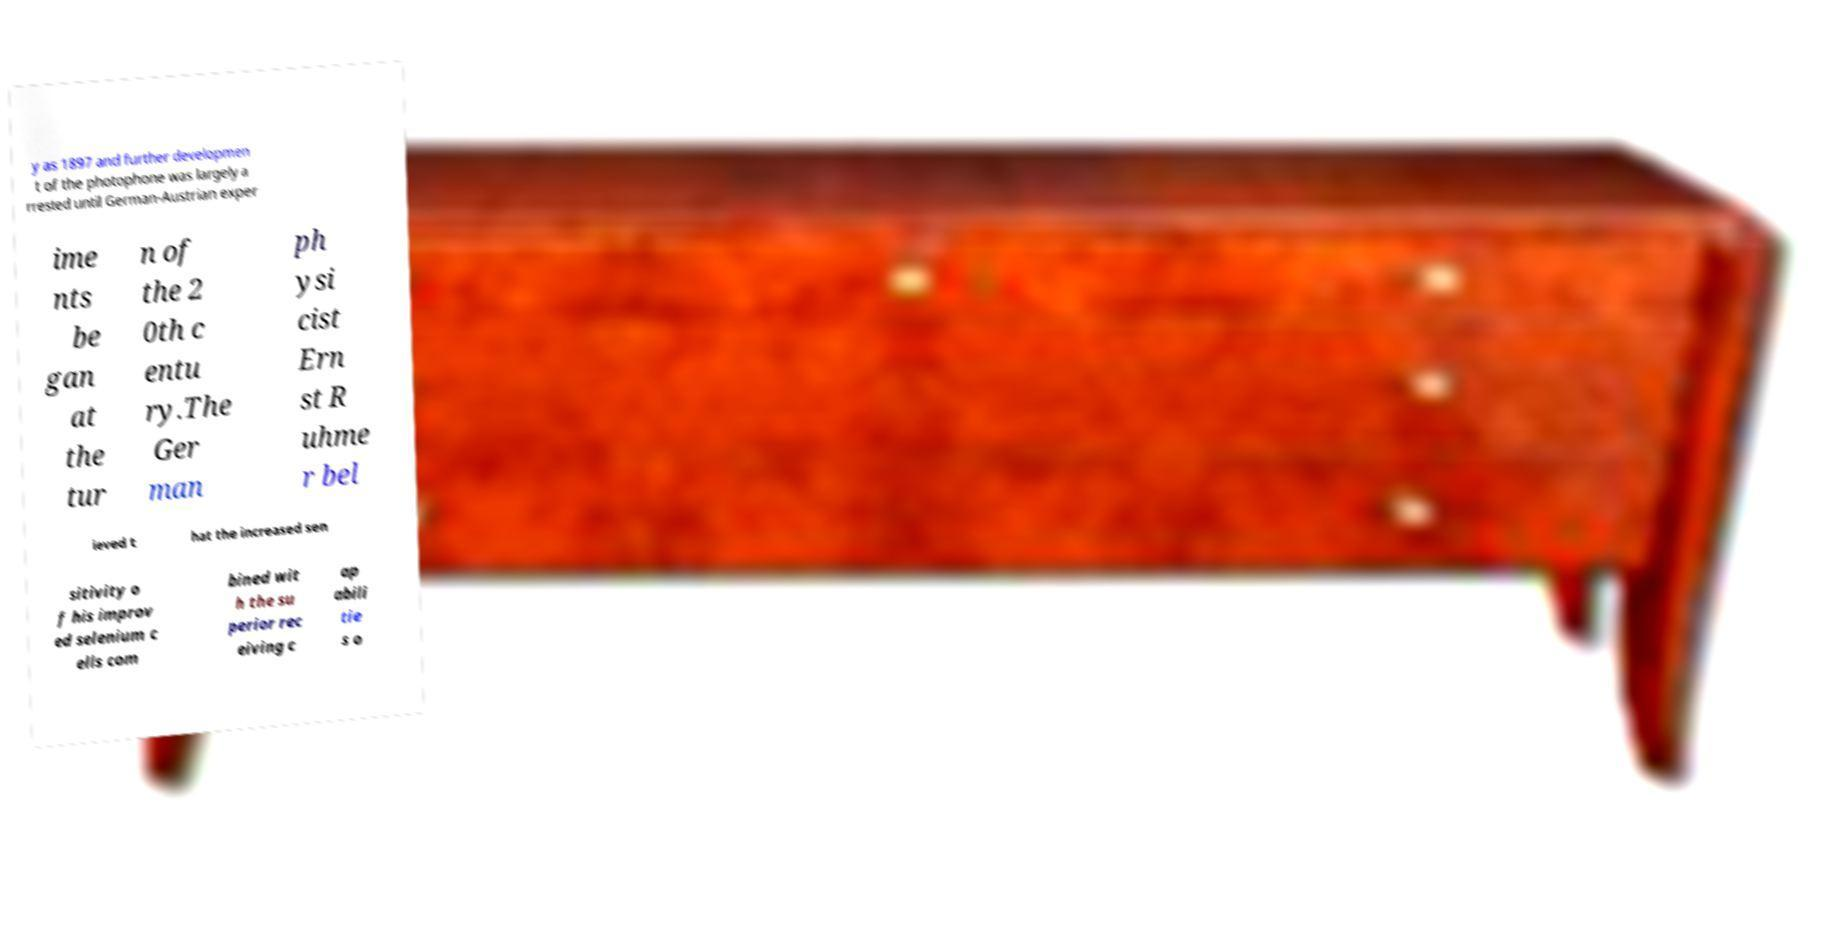For documentation purposes, I need the text within this image transcribed. Could you provide that? y as 1897 and further developmen t of the photophone was largely a rrested until German-Austrian exper ime nts be gan at the tur n of the 2 0th c entu ry.The Ger man ph ysi cist Ern st R uhme r bel ieved t hat the increased sen sitivity o f his improv ed selenium c ells com bined wit h the su perior rec eiving c ap abili tie s o 